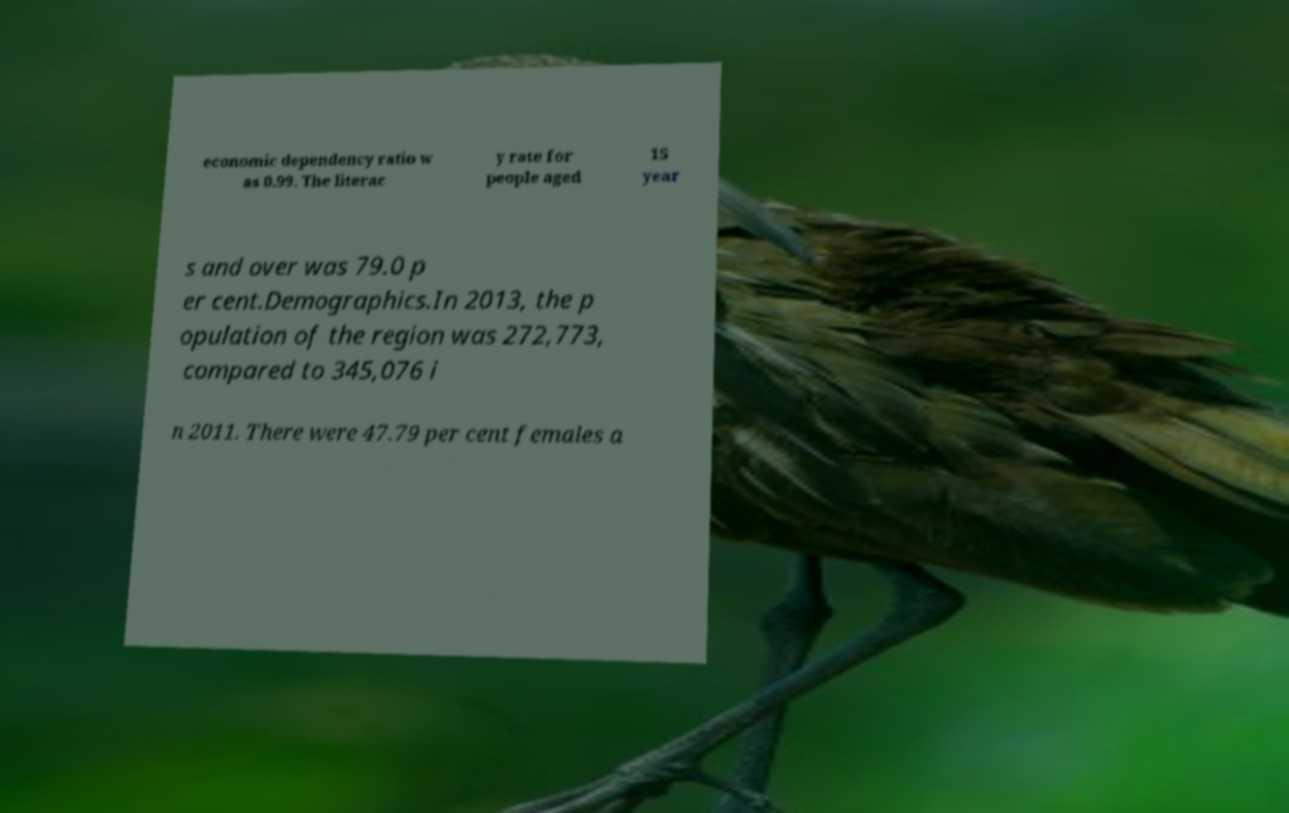Can you read and provide the text displayed in the image?This photo seems to have some interesting text. Can you extract and type it out for me? economic dependency ratio w as 0.99. The literac y rate for people aged 15 year s and over was 79.0 p er cent.Demographics.In 2013, the p opulation of the region was 272,773, compared to 345,076 i n 2011. There were 47.79 per cent females a 